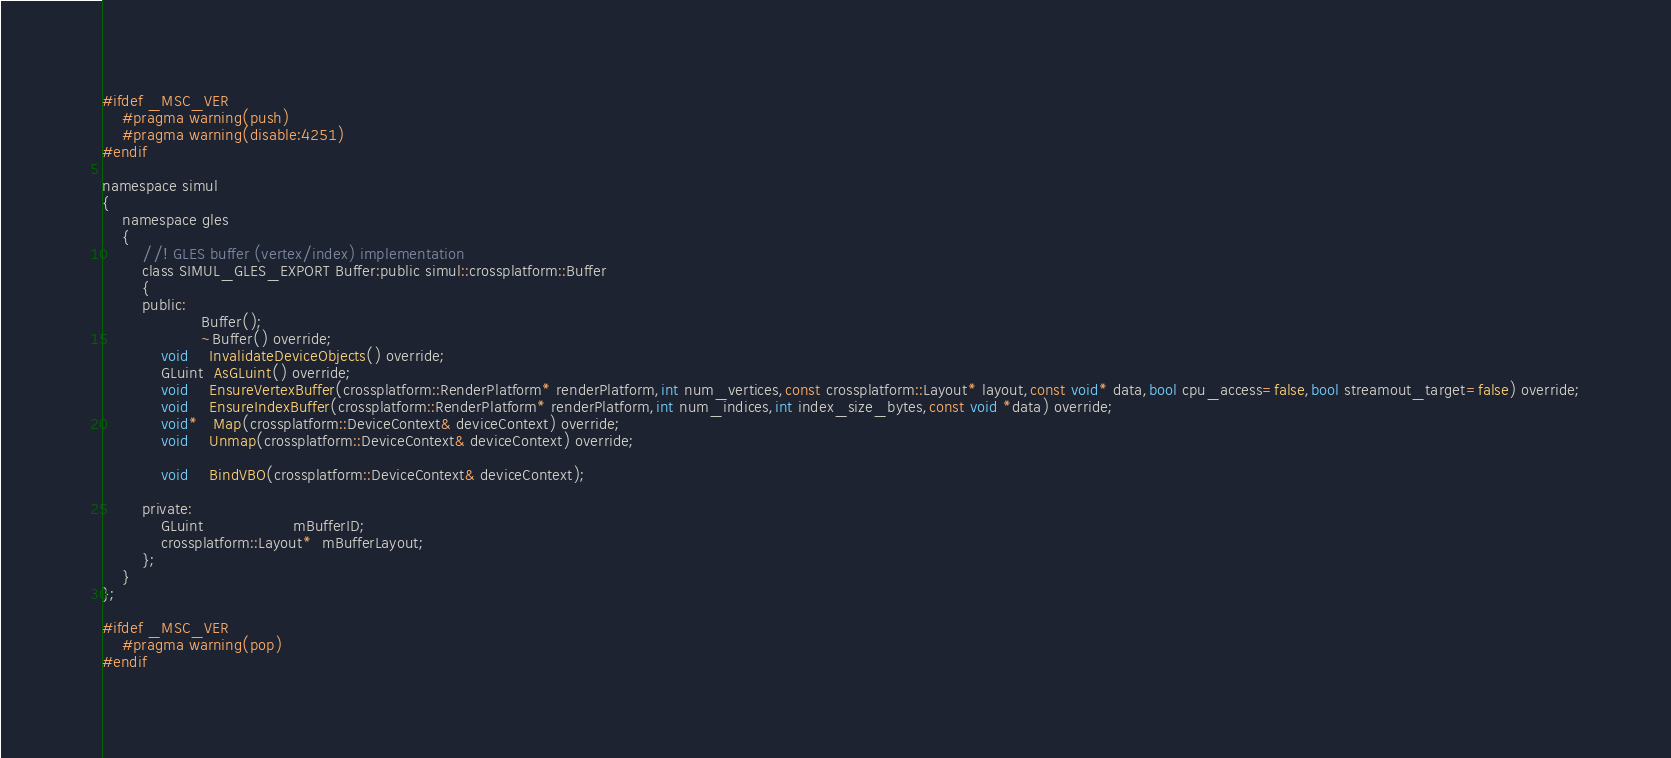<code> <loc_0><loc_0><loc_500><loc_500><_C_>#ifdef _MSC_VER
    #pragma warning(push)
    #pragma warning(disable:4251)
#endif

namespace simul
{
	namespace gles
	{
        //! GLES buffer (vertex/index) implementation
		class SIMUL_GLES_EXPORT Buffer:public simul::crossplatform::Buffer
		{
		public:
			        Buffer();
					~Buffer() override;
			void    InvalidateDeviceObjects() override;
			GLuint  AsGLuint() override;
			void    EnsureVertexBuffer(crossplatform::RenderPlatform* renderPlatform,int num_vertices,const crossplatform::Layout* layout,const void* data,bool cpu_access=false,bool streamout_target=false) override;
			void    EnsureIndexBuffer(crossplatform::RenderPlatform* renderPlatform,int num_indices,int index_size_bytes,const void *data) override;
			void*   Map(crossplatform::DeviceContext& deviceContext) override;
			void    Unmap(crossplatform::DeviceContext& deviceContext) override;

            void    BindVBO(crossplatform::DeviceContext& deviceContext);

        private:
            GLuint                  mBufferID;
            crossplatform::Layout*  mBufferLayout;
		};
	}
};

#ifdef _MSC_VER
    #pragma warning(pop)
#endif
</code> 